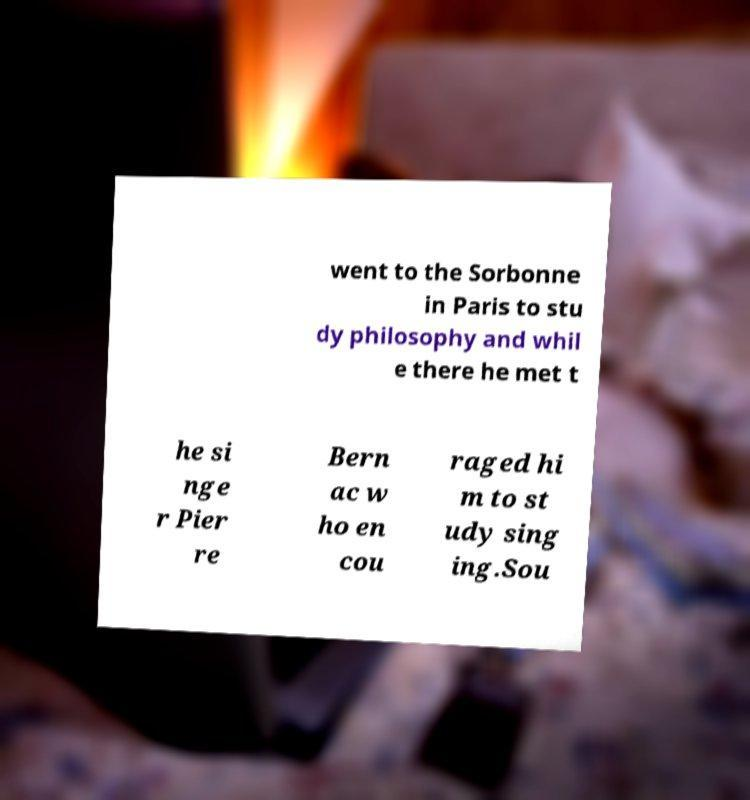Please identify and transcribe the text found in this image. went to the Sorbonne in Paris to stu dy philosophy and whil e there he met t he si nge r Pier re Bern ac w ho en cou raged hi m to st udy sing ing.Sou 